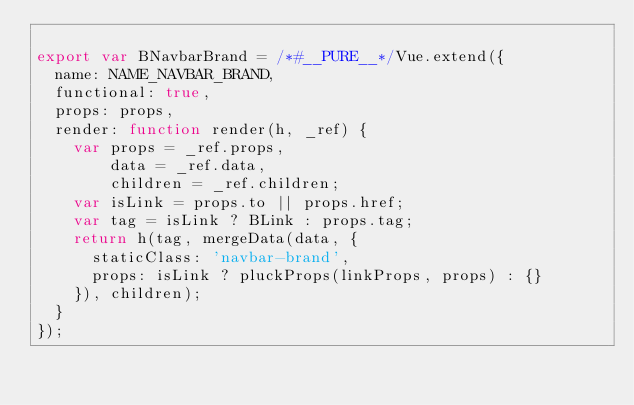<code> <loc_0><loc_0><loc_500><loc_500><_JavaScript_>
export var BNavbarBrand = /*#__PURE__*/Vue.extend({
  name: NAME_NAVBAR_BRAND,
  functional: true,
  props: props,
  render: function render(h, _ref) {
    var props = _ref.props,
        data = _ref.data,
        children = _ref.children;
    var isLink = props.to || props.href;
    var tag = isLink ? BLink : props.tag;
    return h(tag, mergeData(data, {
      staticClass: 'navbar-brand',
      props: isLink ? pluckProps(linkProps, props) : {}
    }), children);
  }
});</code> 